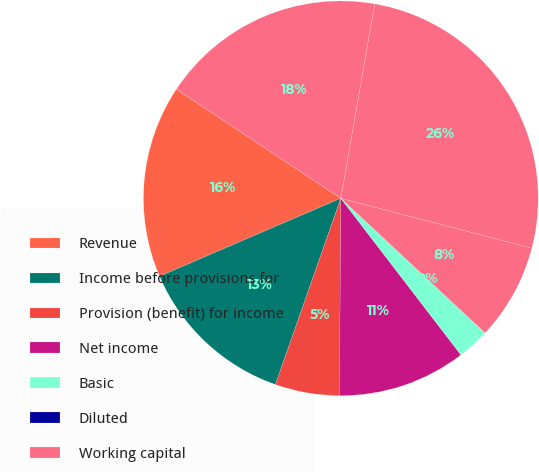<chart> <loc_0><loc_0><loc_500><loc_500><pie_chart><fcel>Revenue<fcel>Income before provisions for<fcel>Provision (benefit) for income<fcel>Net income<fcel>Basic<fcel>Diluted<fcel>Working capital<fcel>Total assets<fcel>Stockholders' equity<nl><fcel>15.79%<fcel>13.16%<fcel>5.26%<fcel>10.53%<fcel>2.63%<fcel>0.0%<fcel>7.89%<fcel>26.32%<fcel>18.42%<nl></chart> 